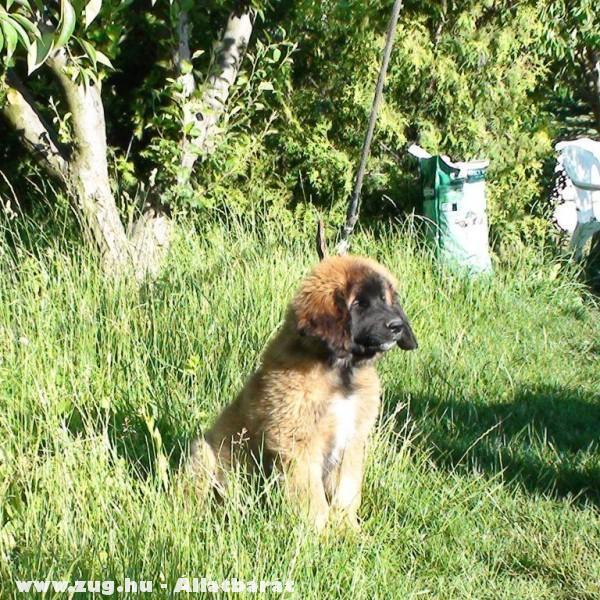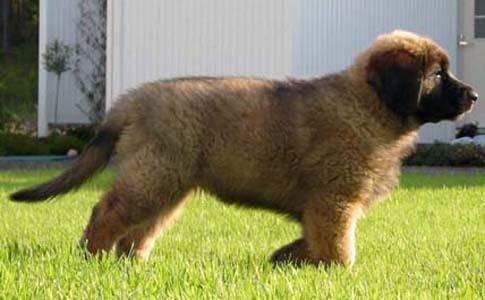The first image is the image on the left, the second image is the image on the right. Considering the images on both sides, is "In one of the images there is a large dog next to a trophy." valid? Answer yes or no. No. The first image is the image on the left, the second image is the image on the right. Considering the images on both sides, is "A trophy stands in the grass next to a dog in one image." valid? Answer yes or no. No. 